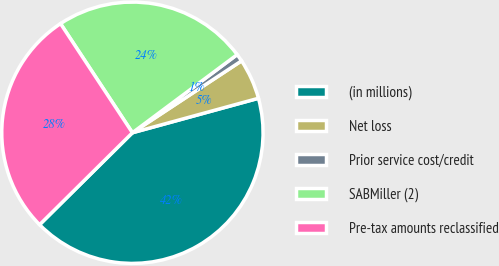Convert chart to OTSL. <chart><loc_0><loc_0><loc_500><loc_500><pie_chart><fcel>(in millions)<fcel>Net loss<fcel>Prior service cost/credit<fcel>SABMiller (2)<fcel>Pre-tax amounts reclassified<nl><fcel>41.82%<fcel>5.02%<fcel>0.93%<fcel>24.07%<fcel>28.15%<nl></chart> 